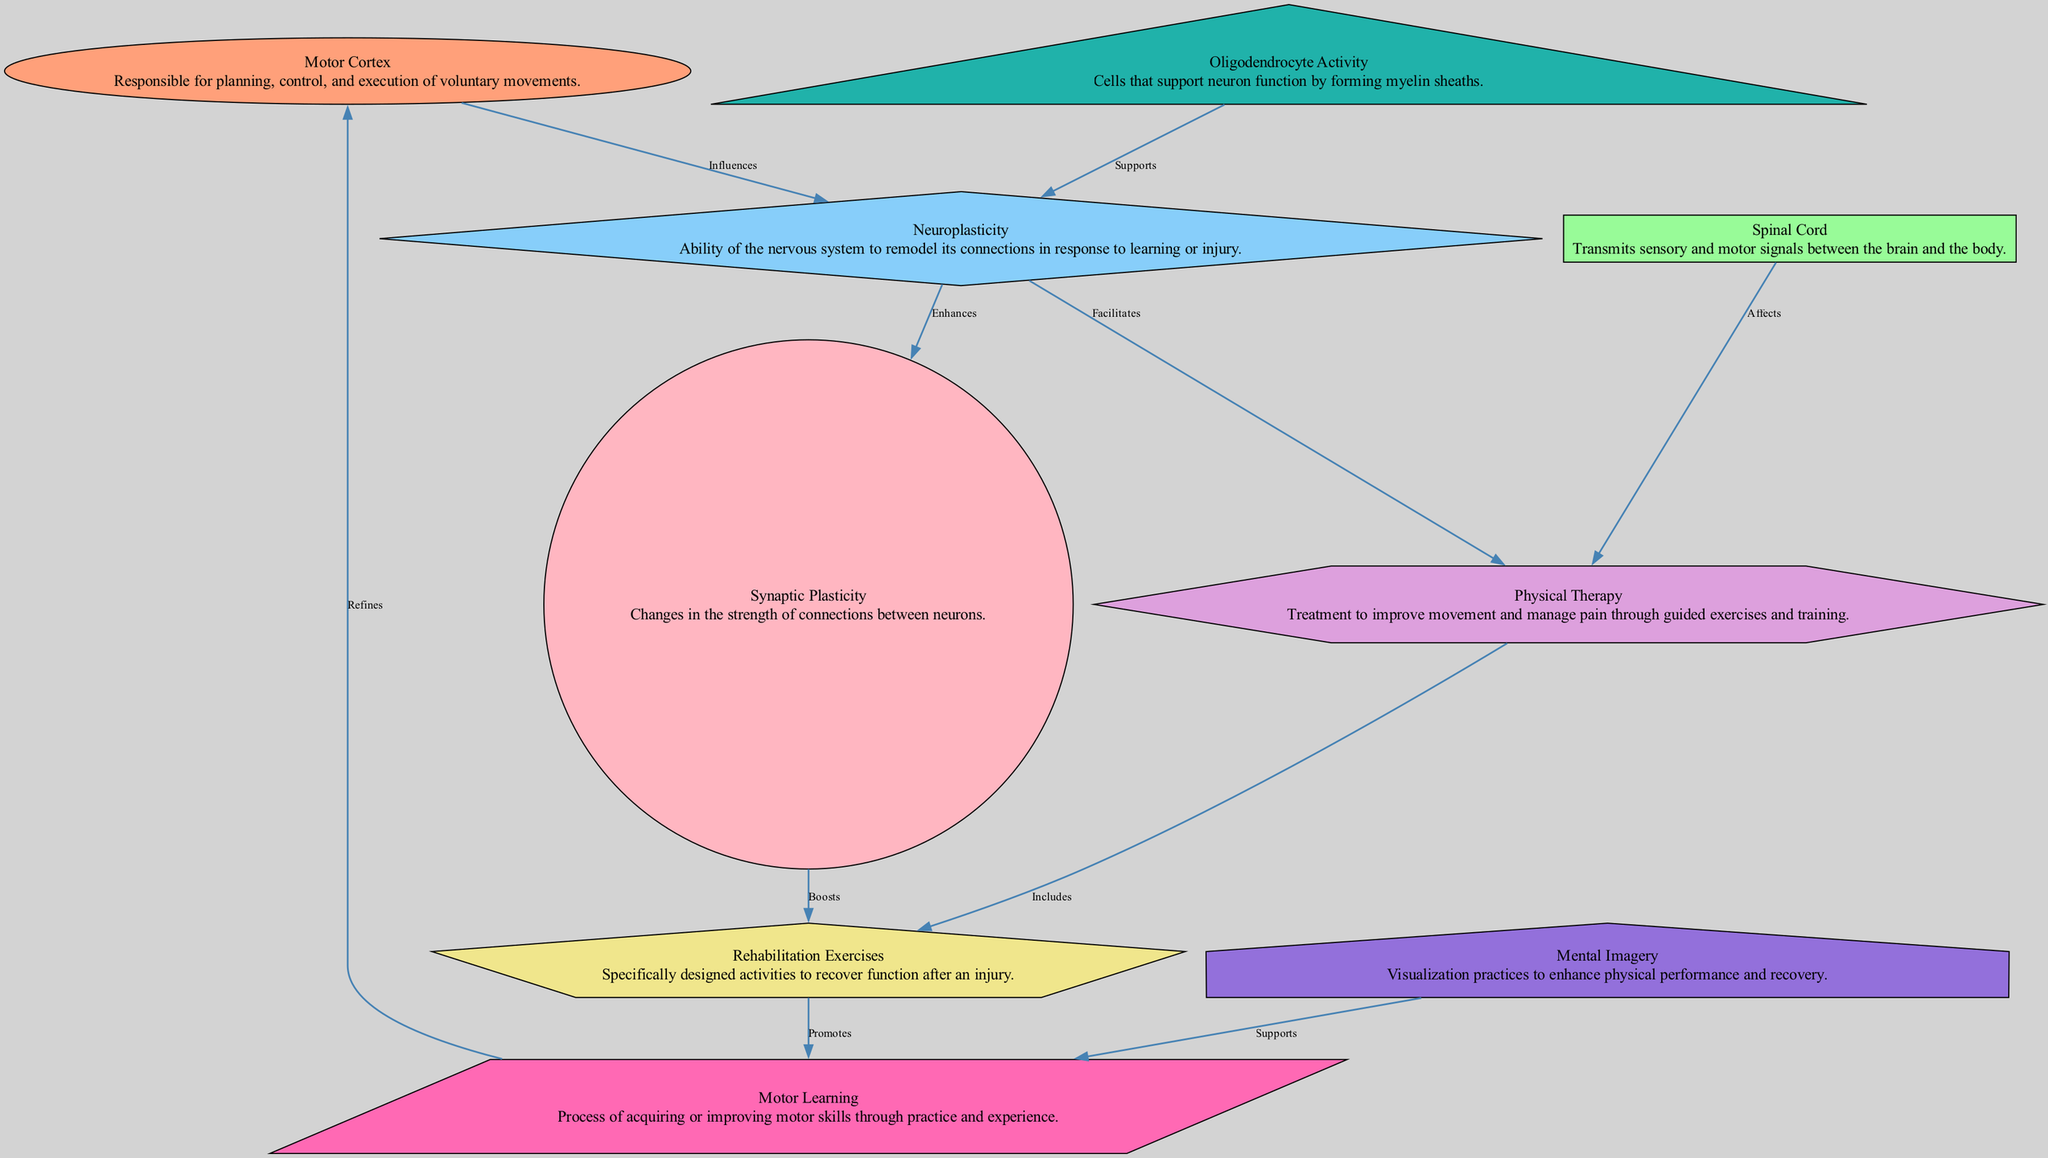What is the role of the Motor Cortex? The Motor Cortex is described as being responsible for planning, control, and execution of voluntary movements. This information is derived directly from the label and description associated with the 'Cortex' node in the diagram.
Answer: Responsible for planning, control, and execution of voluntary movements How many nodes are present in the diagram? By counting the number of unique nodes listed in the data section, there are a total of nine nodes (Cortex, Spine, Neuroplasticity, Therapy, Rehab, Synapse, Oligodendrocyte, Motor Learning, Mental Imagery).
Answer: Nine What relationship does Neuroplasticity have with the Spinal Cord? The diagram indicates that Neuroplasticity does not have a direct edge leading to or from the Spinal Cord. Instead, it shows a relationship with other nodes, including ‘Therapy’ that affects the Spinal Cord indirectly, but no direct link to Spinal Cord itself exists in the diagram.
Answer: No direct relationship Which node promotes Motor Learning? The diagram clearly indicates that the 'Rehabilitation Exercises' node promotes Motor Learning, as portrayed by the direct connection ('Promotes') between 'Rehab' and 'Motor Learning'.
Answer: Rehabilitation Exercises What supports the process of Neuroplasticity? The diagram states that Oligodendrocyte Activity supports Neuroplasticity, indicated by the edge labeled 'Supports' from 'Oligodendrocyte' to 'Neuroplasticity'.
Answer: Oligodendrocyte Activity How does Synaptic Plasticity influence Rehabilitation Exercises? According to the diagram, Synaptic Plasticity enhances connections between neurons (Neuroplasticity) and boosts Rehabilitation Exercises through a direct connection labeled 'Boosts'. Therefore, Synaptic Plasticity has a supportive role in enhancing the effectiveness of Rehab activities.
Answer: Boosts What does Mental Imagery support? The diagram states that Mental Imagery supports Motor Learning, represented by the edge connecting 'Mental Imagery' to 'Motor Learning', labeled 'Supports'.
Answer: Motor Learning Which node influences Neuroplasticity? The edge labeled 'Influences' indicates that the Motor Cortex influences Neuroplasticity, showing a direct connection from the 'Cortex' node to the 'Neuroplasticity' node.
Answer: Motor Cortex How many edges connect the Neuroplasticity node to other nodes? By reviewing the edges associated with the Neuroplasticity node, we find that there are four edges connecting it to other nodes: one to 'Cortex', one to 'Therapy', one to 'Synapse', and one to 'Oligodendrocyte', totaling four connections.
Answer: Four 